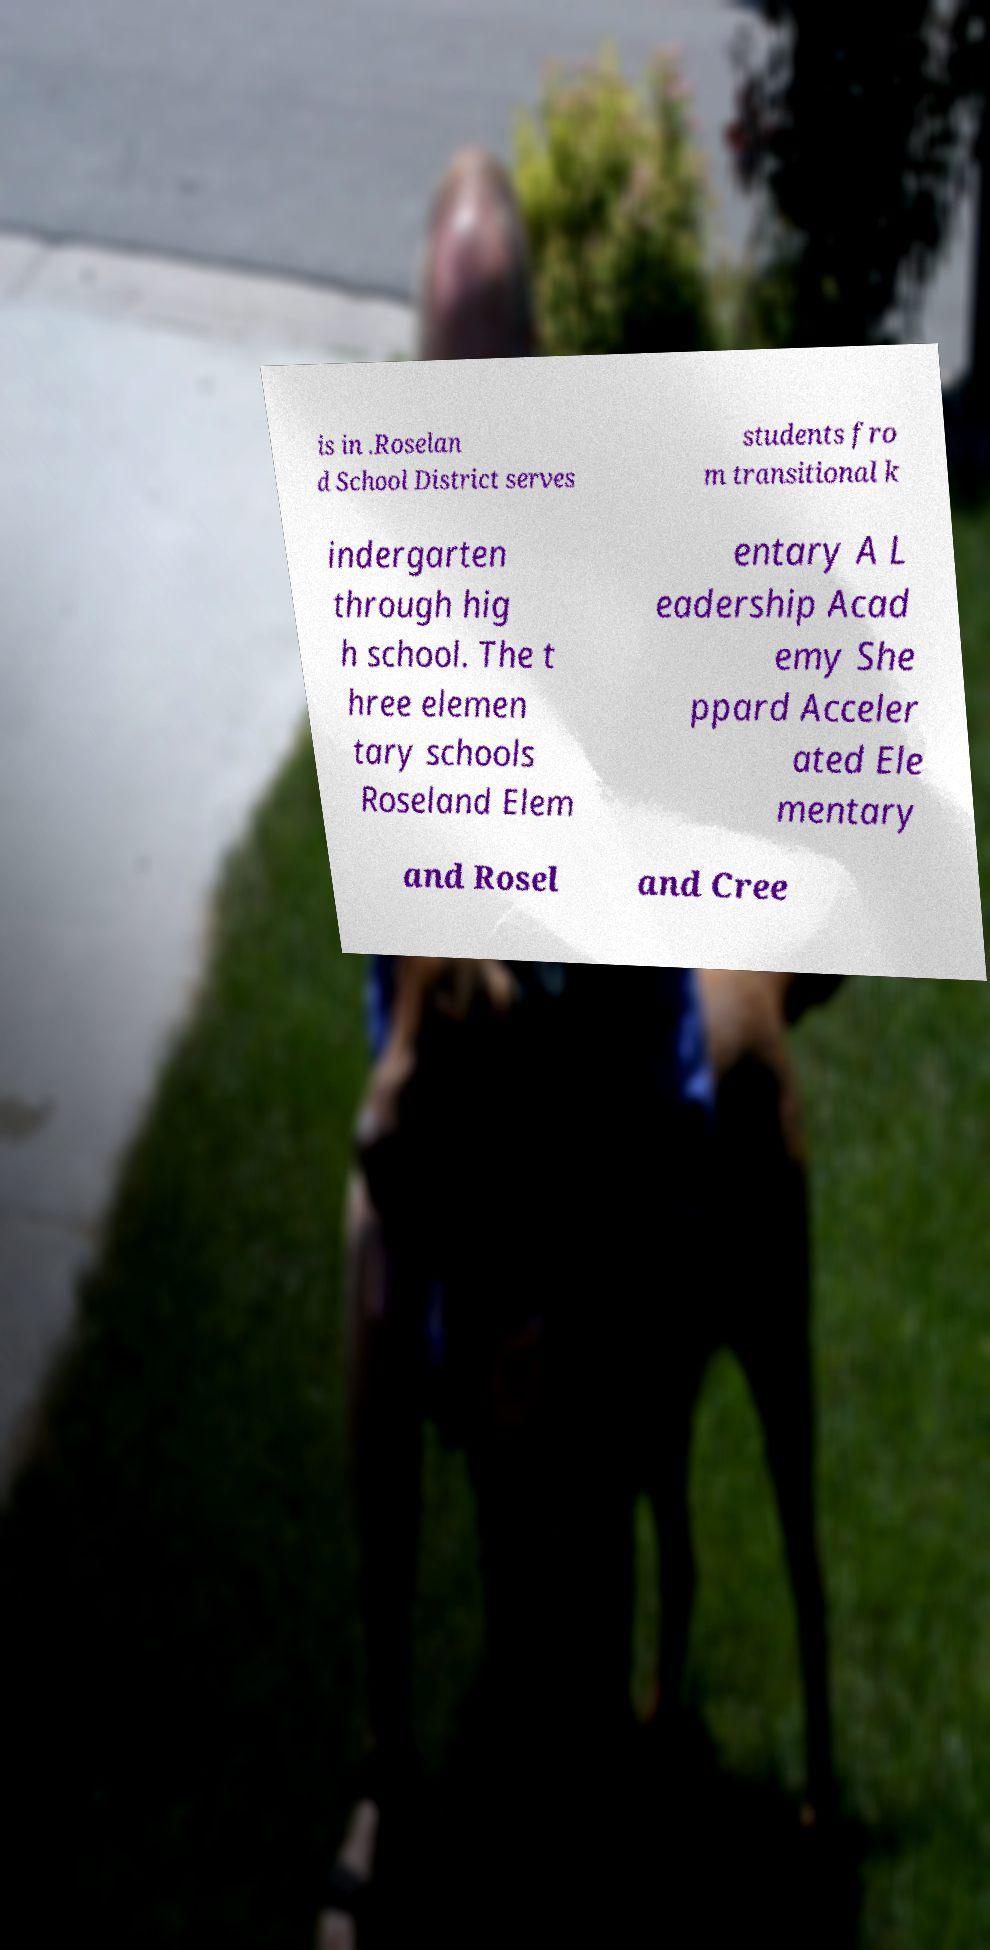Could you assist in decoding the text presented in this image and type it out clearly? is in .Roselan d School District serves students fro m transitional k indergarten through hig h school. The t hree elemen tary schools Roseland Elem entary A L eadership Acad emy She ppard Acceler ated Ele mentary and Rosel and Cree 